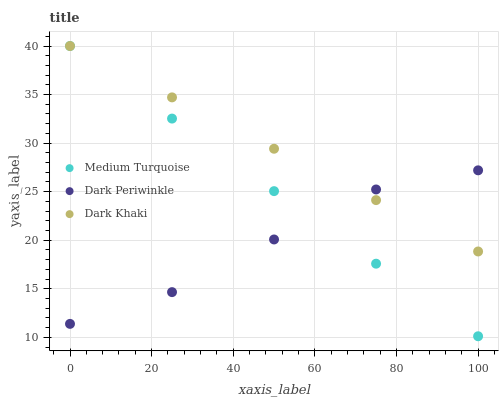Does Dark Periwinkle have the minimum area under the curve?
Answer yes or no. Yes. Does Dark Khaki have the maximum area under the curve?
Answer yes or no. Yes. Does Medium Turquoise have the minimum area under the curve?
Answer yes or no. No. Does Medium Turquoise have the maximum area under the curve?
Answer yes or no. No. Is Medium Turquoise the smoothest?
Answer yes or no. Yes. Is Dark Periwinkle the roughest?
Answer yes or no. Yes. Is Dark Periwinkle the smoothest?
Answer yes or no. No. Is Medium Turquoise the roughest?
Answer yes or no. No. Does Medium Turquoise have the lowest value?
Answer yes or no. Yes. Does Dark Periwinkle have the lowest value?
Answer yes or no. No. Does Medium Turquoise have the highest value?
Answer yes or no. Yes. Does Dark Periwinkle have the highest value?
Answer yes or no. No. Does Dark Khaki intersect Dark Periwinkle?
Answer yes or no. Yes. Is Dark Khaki less than Dark Periwinkle?
Answer yes or no. No. Is Dark Khaki greater than Dark Periwinkle?
Answer yes or no. No. 